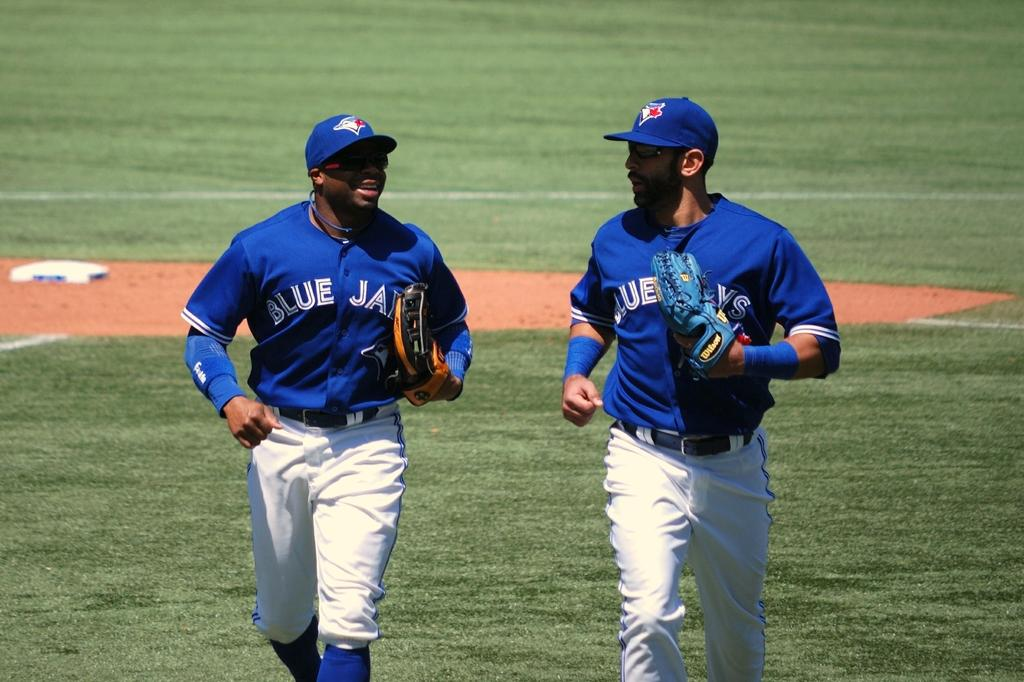<image>
Provide a brief description of the given image. Two Major League Baseball players for the Toronto Bluejays are jogging across the baseball field. 